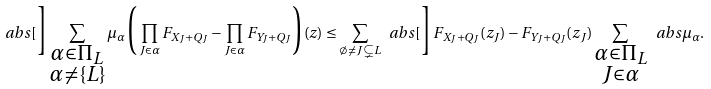<formula> <loc_0><loc_0><loc_500><loc_500>\ a b s [ \Big ] { \sum _ { \substack { \alpha \in \Pi _ { L } \\ \alpha \neq \{ L \} } } \mu _ { \alpha } \Big ( \prod _ { J \in \alpha } F _ { X _ { J } + Q _ { J } } - \prod _ { J \in \alpha } F _ { Y _ { J } + Q _ { J } } \Big ) ( z ) } \leq \sum _ { \emptyset \neq J \subsetneq L } \ a b s [ \Big ] { F _ { X _ { J } + Q _ { J } } ( z _ { J } ) - F _ { Y _ { J } + Q _ { J } } ( z _ { J } ) } \sum _ { \substack { \alpha \in \Pi _ { L } \\ J \in \alpha } } \ a b s { \mu _ { \alpha } } .</formula> 